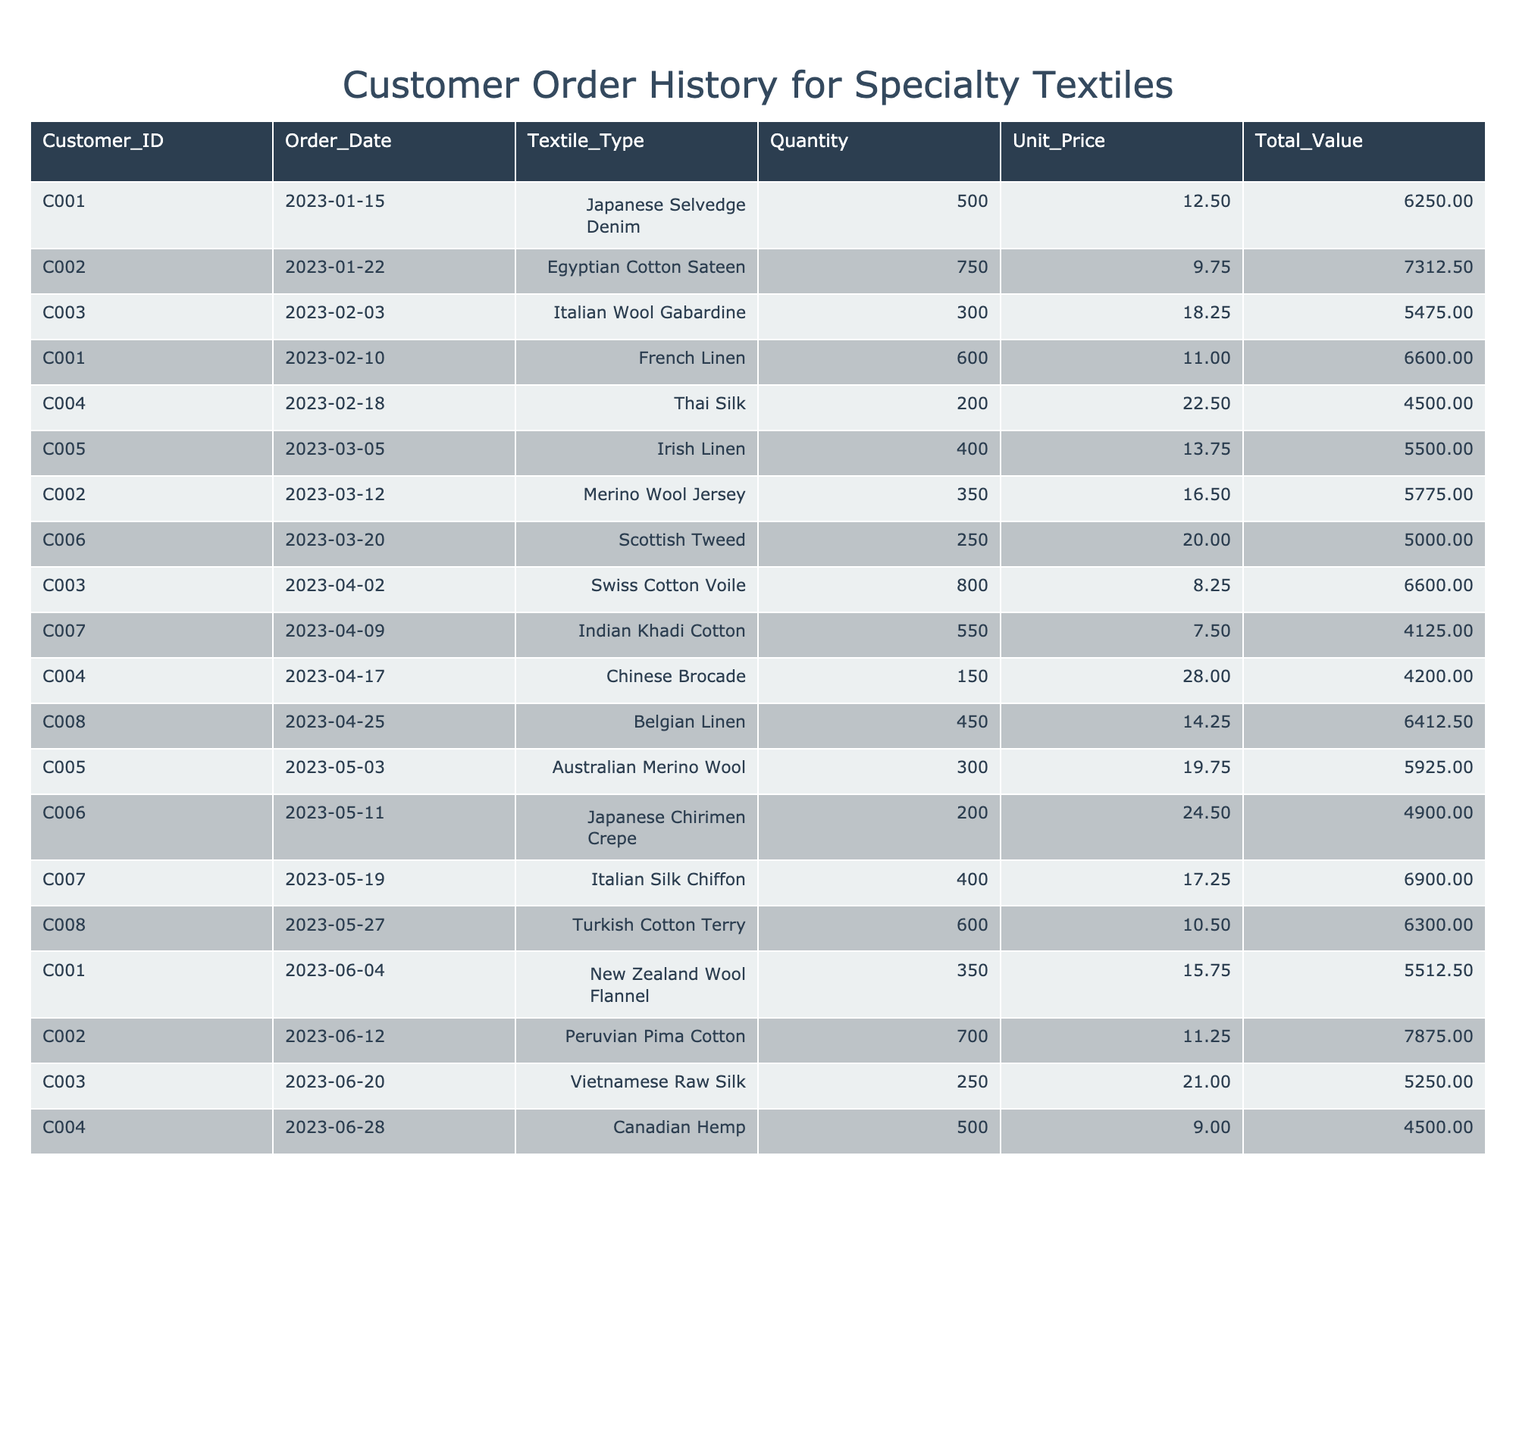What is the total quantity ordered for Japanese Selvedge Denim? There is only one order for Japanese Selvedge Denim from Customer C001, which is 500 units.
Answer: 500 Which customer ordered the most units of fabric? The customer who ordered the most units is Customer C002, with a total of 750 units of Egyptian Cotton Sateen.
Answer: Customer C002 What is the total value of the order placed for Thai Silk? The order for Thai Silk from Customer C004 is for 200 units at a unit price of 22.50. Therefore, the total value is 200 * 22.50 = 4500.
Answer: 4500 How many customers placed orders for Merino Wool? Two separate customers ordered Merino Wool: Customer C002 with 350 units and Customer C005 with 300 units, making a total of two customers.
Answer: 2 What is the average unit price of the textiles ordered? The unit prices are 12.50, 9.75, 18.25, 11.00, 22.50, 13.75, 16.50, 20.00, 8.25, 7.50, 28.00, 14.25, 19.75, 24.50, 17.25, 10.50, 15.75, 11.25, 21.00, and 9.00. Summing these gives 292.00, and there are 20 prices, so the average is 292.00 / 20 = 14.60.
Answer: 14.60 Did Customer C007 purchase any silk products? Customer C007 ordered Italian Silk Chiffon, which is a silk product, confirming that they did purchase silk.
Answer: Yes What is the total quantity ordered by Customer C001? Customer C001 ordered Japanese Selvedge Denim (500), French Linen (600), and New Zealand Wool Flannel (350). The total quantity is 500 + 600 + 350 = 1450.
Answer: 1450 Which textile type has the highest unit price? The textile type with the highest unit price is Chinese Brocade, priced at 28.00 per unit.
Answer: Chinese Brocade What is the total value of all orders made in March 2023? The orders in March are for Irish Linen (400 * 13.75 = 5500), Merino Wool Jersey (350 * 16.50 = 5775), Scottish Tweed (250 * 20.00 = 5000). Summing these totals gives 5500 + 5775 + 5000 = 16275.
Answer: 16275 How many total orders were placed for Swiss Cotton Voile? There is only one order for Swiss Cotton Voile, which was placed by Customer C003 for 800 units.
Answer: 1 Is there a customer who ordered both Egyptian Cotton Sateen and Peruvian Pima Cotton? No, there are two different customers (C002 for Egyptian Cotton Sateen and C002 for Peruvian Pima Cotton), but they are the same, confirming there is one customer who ordered both.
Answer: Yes 